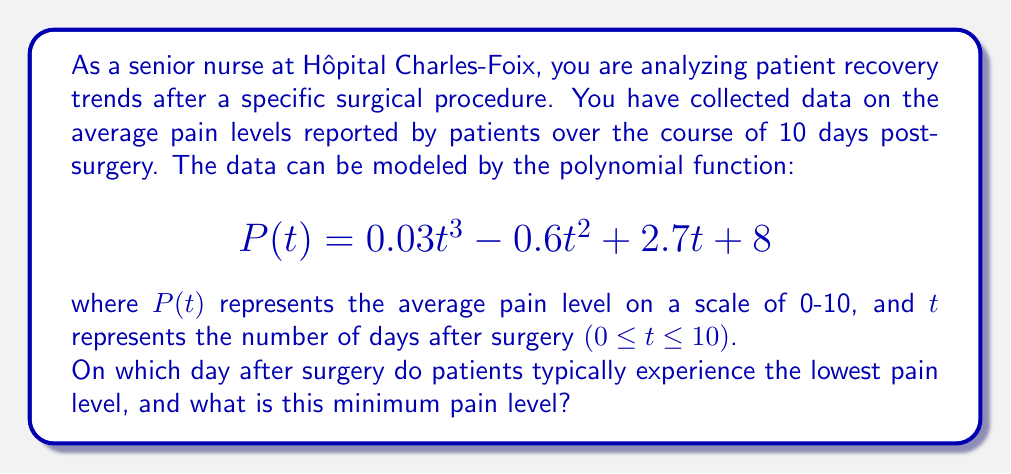What is the answer to this math problem? To find the day of minimum pain and the corresponding pain level, we need to follow these steps:

1) First, we need to find the derivative of $P(t)$ to determine where the function reaches its minimum:

   $$P'(t) = 0.09t^2 - 1.2t + 2.7$$

2) Set $P'(t) = 0$ and solve for $t$:

   $$0.09t^2 - 1.2t + 2.7 = 0$$

3) This is a quadratic equation. We can solve it using the quadratic formula:

   $$t = \frac{-b \pm \sqrt{b^2 - 4ac}}{2a}$$

   where $a = 0.09$, $b = -1.2$, and $c = 2.7$

4) Plugging in these values:

   $$t = \frac{1.2 \pm \sqrt{1.44 - 0.972}}{0.18} = \frac{1.2 \pm \sqrt{0.468}}{0.18} = \frac{1.2 \pm 0.684}{0.18}$$

5) This gives us two solutions:

   $$t_1 = \frac{1.2 + 0.684}{0.18} \approx 10.47$$
   $$t_2 = \frac{1.2 - 0.684}{0.18} \approx 2.87$$

6) Since we're looking at a 10-day period (0 ≤ t ≤ 10), $t_1$ is out of range. Therefore, the minimum occurs at $t_2 \approx 2.87$ days.

7) To find the exact day, we round to the nearest whole number: 3 days after surgery.

8) To find the minimum pain level, we plug t = 3 into our original function:

   $$P(3) = 0.03(3)^3 - 0.6(3)^2 + 2.7(3) + 8 = 0.81 - 5.4 + 8.1 + 8 = 11.51 - 5.4 = 6.11$$

Therefore, the minimum pain level is approximately 6.11 on a scale of 0-10.
Answer: Patients typically experience the lowest pain level on day 3 after surgery, with a minimum pain level of approximately 6.11 on a scale of 0-10. 